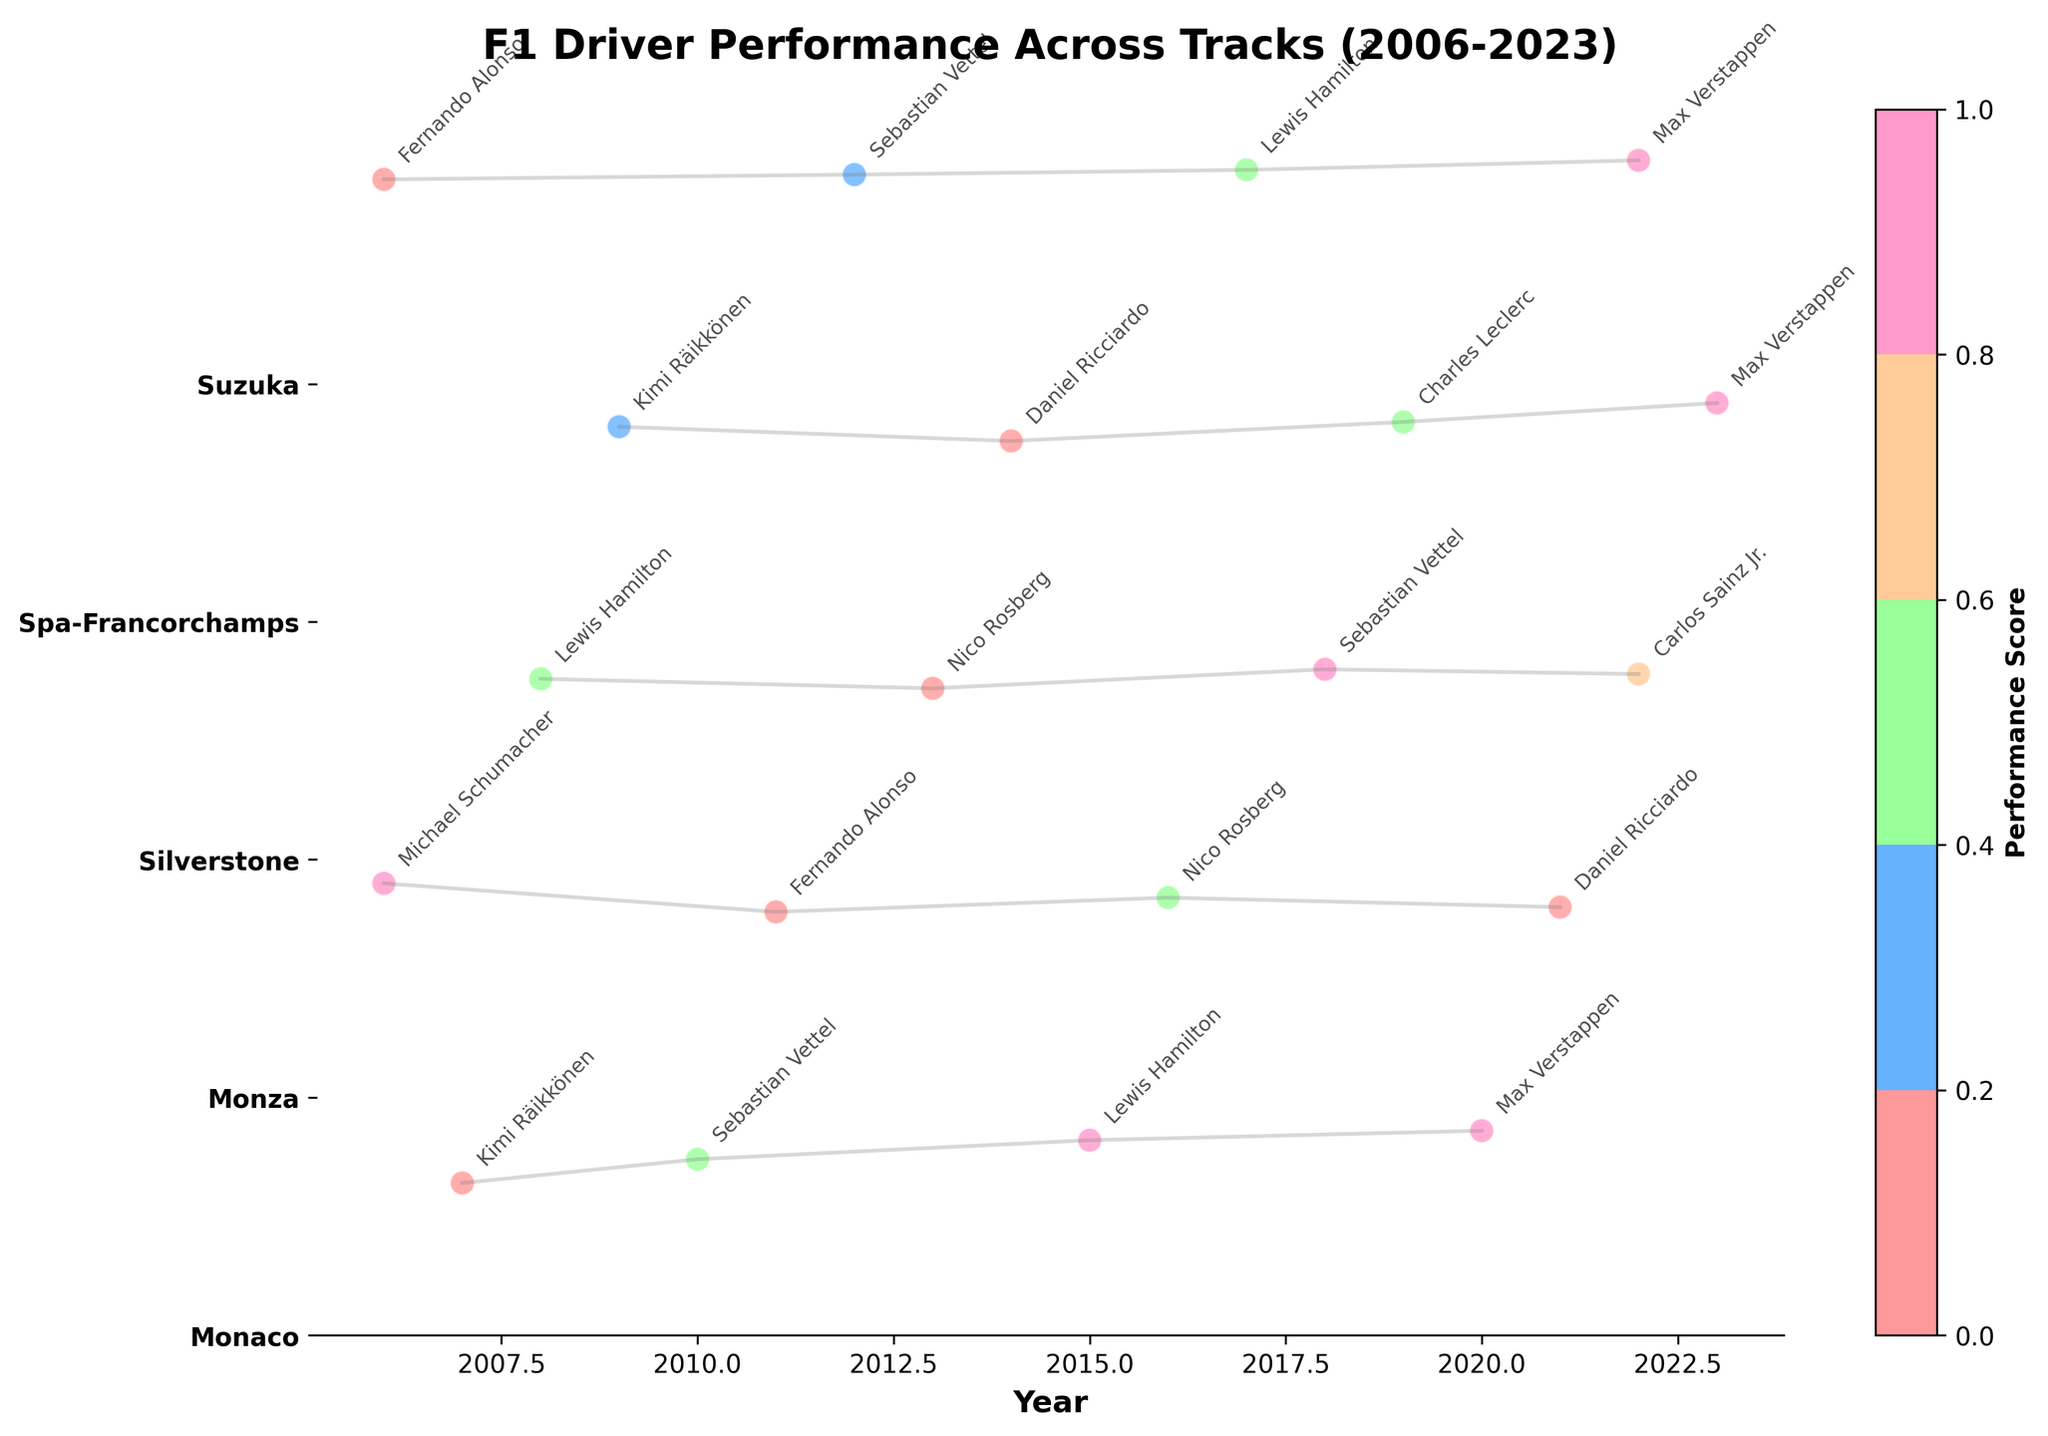What is the title of the plot? The title of the plot is written at the top and in a large font. It reads 'F1 Driver Performance Across Tracks (2006-2023)'.
Answer: F1 Driver Performance Across Tracks (2006-2023) What is the color bar representing in the plot? The color bar, which is shown as a gradient, represents the 'Performance Score'. This is indicated by the label 'Performance Score' next to the color bar.
Answer: Performance Score Which track has the highest performance score and who is the driver? To determine the highest performance score, look for the data point with the darkest color on the color bar. The highest score is 9.7 at Suzuka, achieved by Max Verstappen in 2022.
Answer: Suzuka, Max Verstappen How many tracks are represented in the plot? Count the unique track labels on the y-axis of the plot. There are 5 tracks listed in the y-axis labels: Monaco, Monza, Silverstone, Spa-Francorchamps, and Suzuka.
Answer: 5 Which driver has the highest performance score at Monza? Look at the data points for the Monza track. The highest score here is shown with the darkest color, which corresponds to Michael Schumacher with a score of 9.5 in 2006.
Answer: Michael Schumacher In which year was Lewis Hamilton's lowest performance score at Silverstone, and what was the score? Focus on Lewis Hamilton's data points at Silverstone. His points on the plot are for 2008 and 2017. His lower score is in 2008 with a score of 8.8.
Answer: 2008, 8.8 Which track has the smallest range of performance scores among the data points shown? Look at the spread of scores for each track on the plot. Monaco has performance scores ranging between 8.2 and 9.3, a smaller range compared to other tracks.
Answer: Monaco Compare the performance score trends for Sebastian Vettel from 2010 to 2018. Examine the data points for Sebastian Vettel in 2010 at Monaco, 2012 at Suzuka, and 2018 at Silverstone. The scores are 8.7, 9.4, and 9.0 respectively, indicating an increase from 2010 to 2012 and a slight decrease from 2012 to 2018.
Answer: Increased from 2010 to 2012, then decreased to 2018 What is the average performance score of all drivers at Spa-Francorchamps? Sum the performance scores for Spa-Francorchamps: 9.1 (Kimi Räikkönen) + 8.8 (Daniel Ricciardo) + 9.2 (Charles Leclerc) + 9.6 (Max Verstappen). The total is 36.7. Dividing by the number of entries (4) gives an average of 36.7 / 4 = 9.175.
Answer: 9.175 